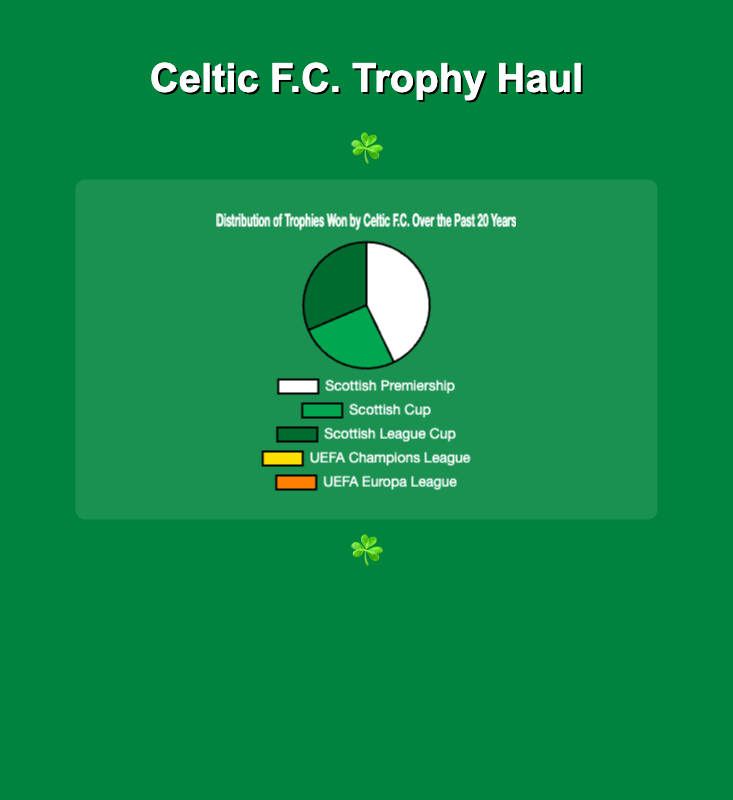Which trophy has Celtic F.C. won the most times in the past 20 years? The figure shows the distribution of trophies won by Celtic F.C. over the past 20 years. By comparing the slices, the Scottish Premiership slice is the largest.
Answer: Scottish Premiership What is the total number of domestic trophies won by Celtic F.C. in the past 20 years? Domestic trophies include the Scottish Premiership, Scottish Cup, and Scottish League Cup. Summing them up, we have 15 (Scottish Premiership) + 9 (Scottish Cup) + 11 (Scottish League Cup) = 35.
Answer: 35 Which European competitions have Celtic F.C. not won any trophies in the past 20 years? The figure shows two slices for the UEFA Champions League and UEFA Europa League, both with a value of 0.
Answer: UEFA Champions League and UEFA Europa League How many more times has Celtic F.C. won the Scottish Premiership than the Scottish Cup? The figure shows that Celtic F.C. has won the Scottish Premiership 15 times and the Scottish Cup 9 times. The difference is 15 - 9 = 6.
Answer: 6 What percentage of the total trophies won is represented by the Scottish League Cup? The total number of trophies is 15 (Scottish Premiership) + 9 (Scottish Cup) + 11 (Scottish League Cup) + 0 (UEFA Champions League) + 0 (UEFA Europa League) = 35. The percentage for the Scottish League Cup is (11 / 35) * 100 ≈ 31.43%.
Answer: 31.43% Which trophy has Celtic F.C. won the least among domestic competitions? Among the domestic competitions (Scottish Premiership, Scottish Cup, Scottish League Cup), the Scottish Cup slice appears smaller than the other two.
Answer: Scottish Cup How many trophies has Celtic F.C. won in total from the figure? Adding all the values for the displayed trophies: 15 (Scottish Premiership) + 9 (Scottish Cup) + 11 (Scottish League Cup) + 0 (UEFA Champions League) + 0 (UEFA Europa League) = 35.
Answer: 35 Between the Scottish Cup and Scottish League Cup, which has Celtic F.C. won more often and by how much? The figure shows 11 wins for the Scottish League Cup and 9 for the Scottish Cup. The difference is 11 - 9 = 2.
Answer: Scottish League Cup by 2 trophies 